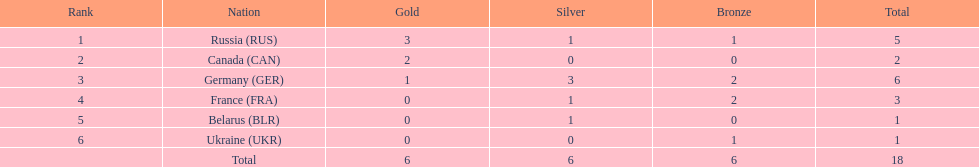Name the country that had the same number of bronze medals as russia. Ukraine. 